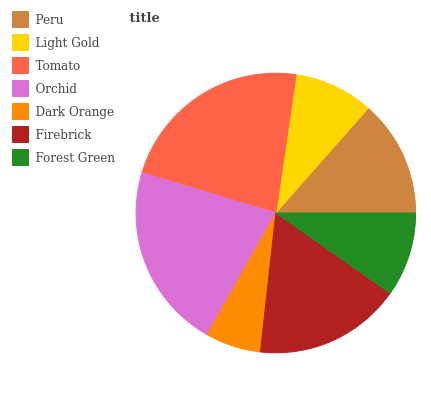Is Dark Orange the minimum?
Answer yes or no. Yes. Is Tomato the maximum?
Answer yes or no. Yes. Is Light Gold the minimum?
Answer yes or no. No. Is Light Gold the maximum?
Answer yes or no. No. Is Peru greater than Light Gold?
Answer yes or no. Yes. Is Light Gold less than Peru?
Answer yes or no. Yes. Is Light Gold greater than Peru?
Answer yes or no. No. Is Peru less than Light Gold?
Answer yes or no. No. Is Peru the high median?
Answer yes or no. Yes. Is Peru the low median?
Answer yes or no. Yes. Is Light Gold the high median?
Answer yes or no. No. Is Tomato the low median?
Answer yes or no. No. 